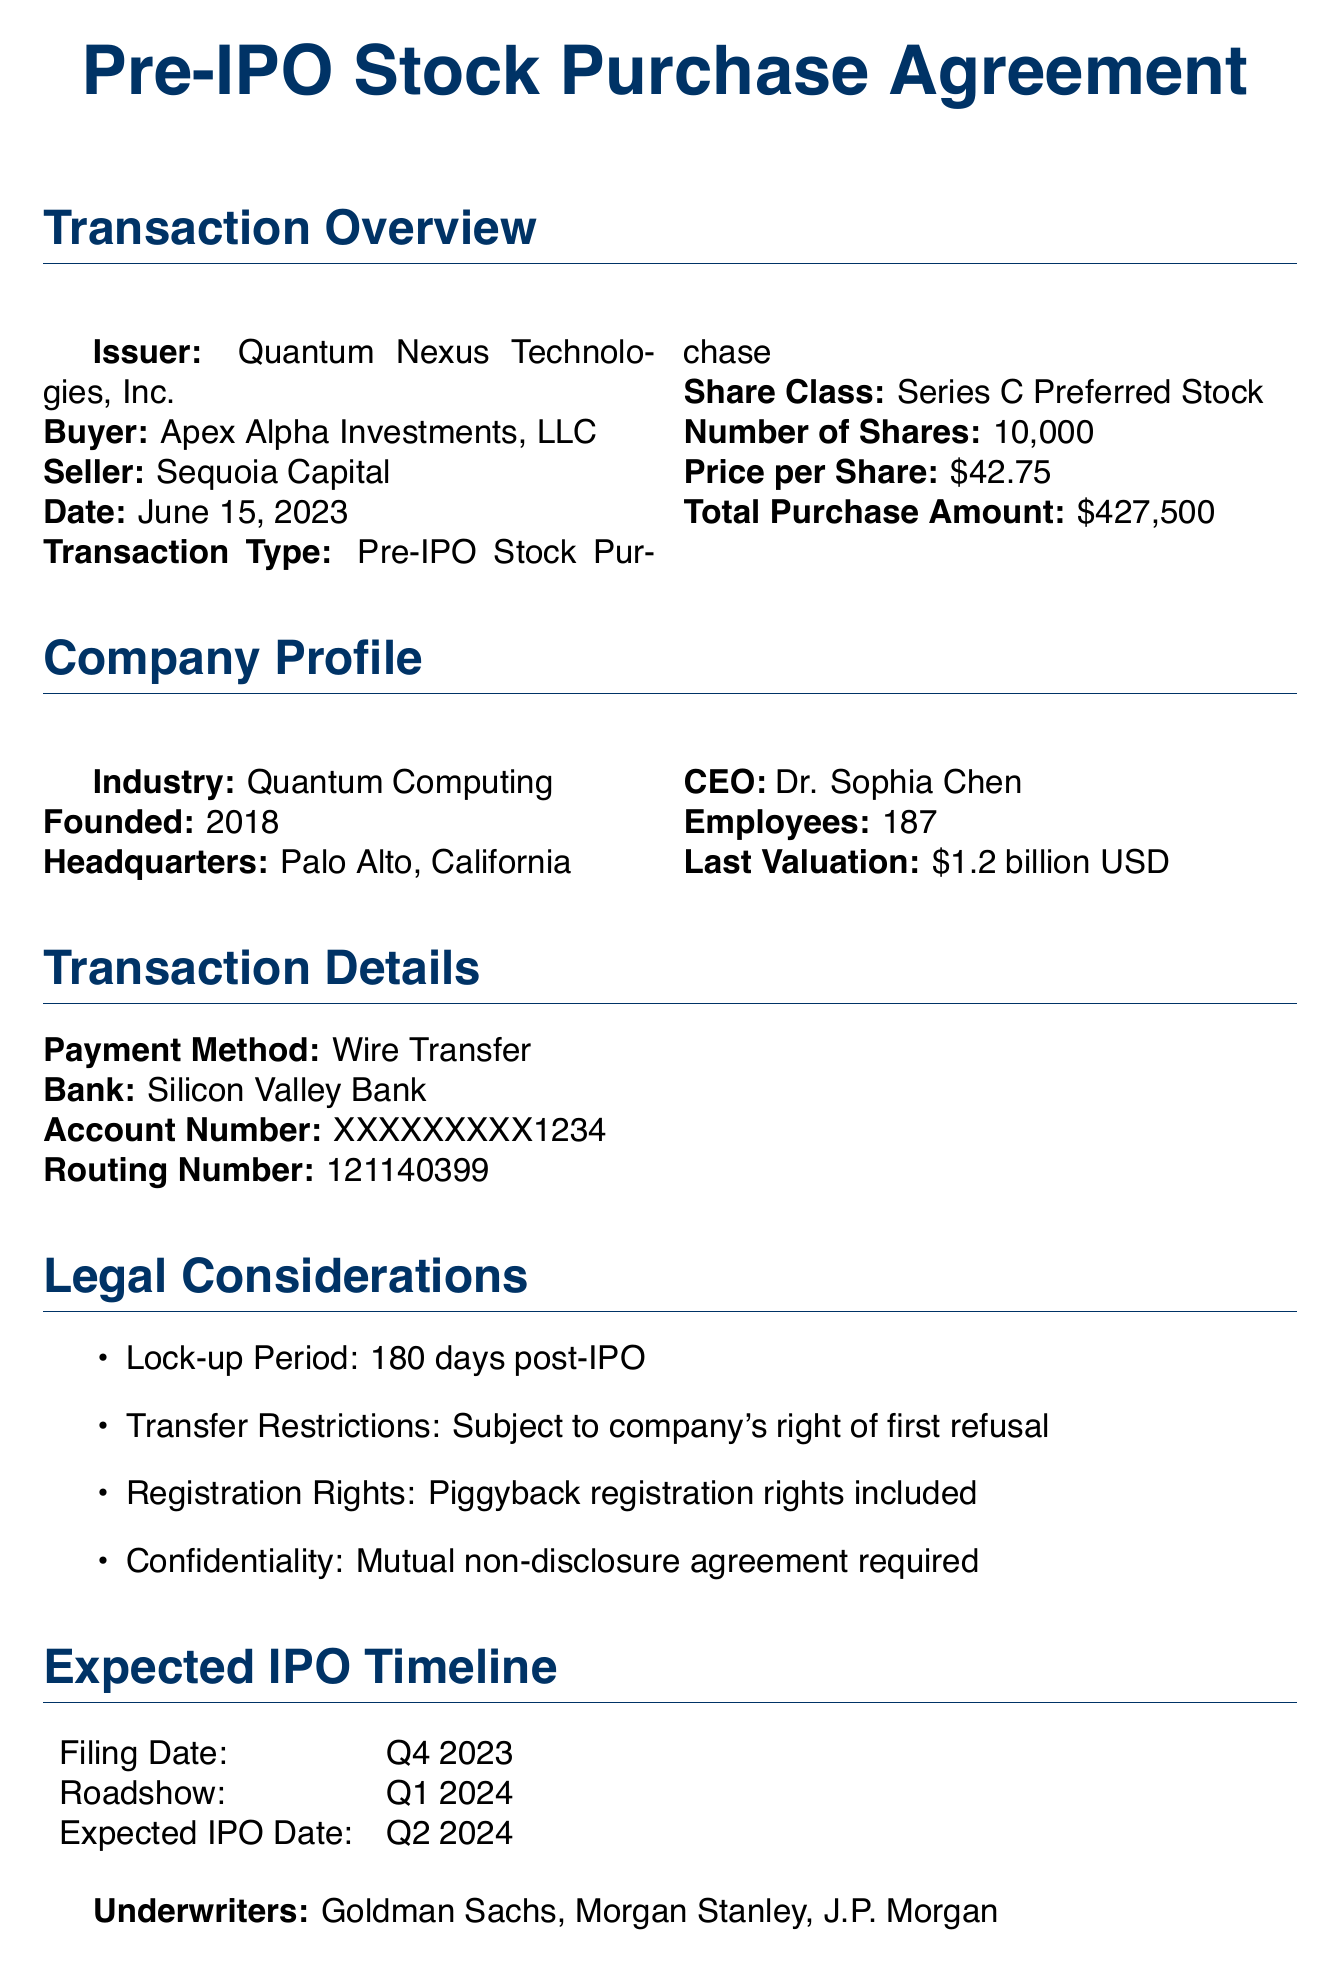What is the name of the seller? The seller of the shares is Sequoia Capital, mentioned under the seller section.
Answer: Sequoia Capital How many shares were purchased? The document states that the number of shares purchased is 10,000.
Answer: 10,000 What is the price per share? The price per share is indicated as $42.75 in the transaction overview.
Answer: $42.75 What is the total purchase amount? The document lists the total purchase amount as $427,500.
Answer: $427,500 Who is the CEO of Quantum Nexus Technologies, Inc.? The CEO mentioned in the company profile is Dr. Sophia Chen.
Answer: Dr. Sophia Chen What is the lock-up period for the shares? The lock-up period specified is 180 days post-IPO.
Answer: 180 days When is the expected IPO date? The expected IPO date is stated as Q2 2024 in the expected IPO timeline.
Answer: Q2 2024 Which bank was used for the wire transfer? The bank specified for the payment method is Silicon Valley Bank.
Answer: Silicon Valley Bank What are the comparable investments listed? The document includes Rigetti Computing, IonQ, and D-Wave Systems as comparable investments.
Answer: Rigetti Computing, IonQ, D-Wave Systems 